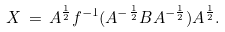<formula> <loc_0><loc_0><loc_500><loc_500>X \, = \, A ^ { \frac { 1 } { 2 } } f ^ { - 1 } ( A ^ { - \frac { 1 } { 2 } } B A ^ { - \frac { 1 } { 2 } } ) A ^ { \frac { 1 } { 2 } } .</formula> 